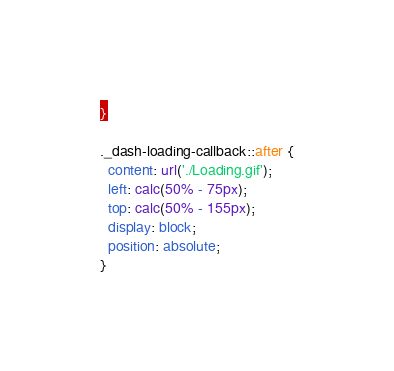<code> <loc_0><loc_0><loc_500><loc_500><_CSS_>}

._dash-loading-callback::after {
  content: url('./Loading.gif');
  left: calc(50% - 75px);
  top: calc(50% - 155px);
  display: block;
  position: absolute;
}
</code> 